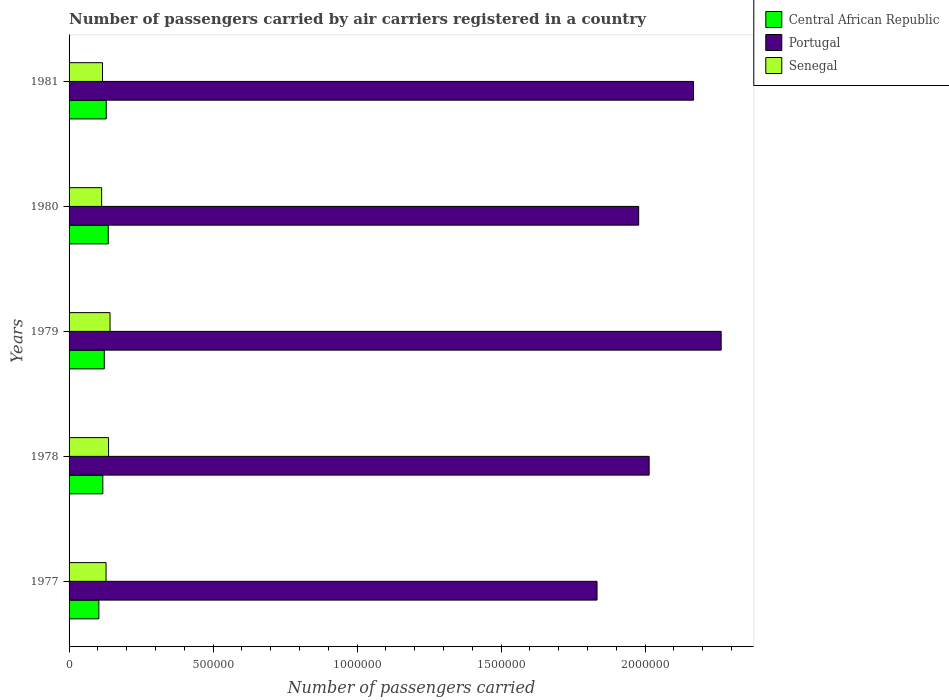What is the label of the 4th group of bars from the top?
Your response must be concise. 1978. What is the number of passengers carried by air carriers in Central African Republic in 1981?
Keep it short and to the point. 1.29e+05. Across all years, what is the maximum number of passengers carried by air carriers in Senegal?
Make the answer very short. 1.42e+05. Across all years, what is the minimum number of passengers carried by air carriers in Portugal?
Offer a very short reply. 1.83e+06. What is the total number of passengers carried by air carriers in Senegal in the graph?
Ensure brevity in your answer.  6.37e+05. What is the difference between the number of passengers carried by air carriers in Senegal in 1977 and that in 1978?
Provide a short and direct response. -8800. What is the difference between the number of passengers carried by air carriers in Portugal in 1981 and the number of passengers carried by air carriers in Central African Republic in 1979?
Provide a short and direct response. 2.05e+06. What is the average number of passengers carried by air carriers in Portugal per year?
Offer a terse response. 2.05e+06. In the year 1977, what is the difference between the number of passengers carried by air carriers in Central African Republic and number of passengers carried by air carriers in Senegal?
Your answer should be very brief. -2.50e+04. In how many years, is the number of passengers carried by air carriers in Central African Republic greater than 1900000 ?
Provide a succinct answer. 0. What is the ratio of the number of passengers carried by air carriers in Portugal in 1977 to that in 1979?
Keep it short and to the point. 0.81. What is the difference between the highest and the second highest number of passengers carried by air carriers in Portugal?
Offer a terse response. 9.60e+04. What is the difference between the highest and the lowest number of passengers carried by air carriers in Central African Republic?
Provide a succinct answer. 3.27e+04. In how many years, is the number of passengers carried by air carriers in Portugal greater than the average number of passengers carried by air carriers in Portugal taken over all years?
Offer a terse response. 2. What does the 1st bar from the top in 1980 represents?
Give a very brief answer. Senegal. How many bars are there?
Make the answer very short. 15. Does the graph contain any zero values?
Make the answer very short. No. Where does the legend appear in the graph?
Offer a terse response. Top right. How many legend labels are there?
Your answer should be very brief. 3. What is the title of the graph?
Your answer should be compact. Number of passengers carried by air carriers registered in a country. What is the label or title of the X-axis?
Offer a very short reply. Number of passengers carried. What is the label or title of the Y-axis?
Your response must be concise. Years. What is the Number of passengers carried in Central African Republic in 1977?
Make the answer very short. 1.03e+05. What is the Number of passengers carried of Portugal in 1977?
Offer a terse response. 1.83e+06. What is the Number of passengers carried of Senegal in 1977?
Your answer should be compact. 1.28e+05. What is the Number of passengers carried in Central African Republic in 1978?
Your response must be concise. 1.17e+05. What is the Number of passengers carried of Portugal in 1978?
Your answer should be compact. 2.01e+06. What is the Number of passengers carried in Senegal in 1978?
Your answer should be very brief. 1.37e+05. What is the Number of passengers carried of Central African Republic in 1979?
Give a very brief answer. 1.22e+05. What is the Number of passengers carried of Portugal in 1979?
Offer a very short reply. 2.26e+06. What is the Number of passengers carried in Senegal in 1979?
Give a very brief answer. 1.42e+05. What is the Number of passengers carried of Central African Republic in 1980?
Give a very brief answer. 1.36e+05. What is the Number of passengers carried in Portugal in 1980?
Make the answer very short. 1.98e+06. What is the Number of passengers carried of Senegal in 1980?
Your answer should be very brief. 1.13e+05. What is the Number of passengers carried in Central African Republic in 1981?
Provide a succinct answer. 1.29e+05. What is the Number of passengers carried of Portugal in 1981?
Make the answer very short. 2.17e+06. What is the Number of passengers carried in Senegal in 1981?
Ensure brevity in your answer.  1.16e+05. Across all years, what is the maximum Number of passengers carried of Central African Republic?
Offer a very short reply. 1.36e+05. Across all years, what is the maximum Number of passengers carried of Portugal?
Give a very brief answer. 2.26e+06. Across all years, what is the maximum Number of passengers carried in Senegal?
Your response must be concise. 1.42e+05. Across all years, what is the minimum Number of passengers carried in Central African Republic?
Provide a short and direct response. 1.03e+05. Across all years, what is the minimum Number of passengers carried in Portugal?
Offer a very short reply. 1.83e+06. Across all years, what is the minimum Number of passengers carried in Senegal?
Your response must be concise. 1.13e+05. What is the total Number of passengers carried in Central African Republic in the graph?
Your response must be concise. 6.08e+05. What is the total Number of passengers carried in Portugal in the graph?
Give a very brief answer. 1.03e+07. What is the total Number of passengers carried of Senegal in the graph?
Offer a terse response. 6.37e+05. What is the difference between the Number of passengers carried of Central African Republic in 1977 and that in 1978?
Your response must be concise. -1.38e+04. What is the difference between the Number of passengers carried in Portugal in 1977 and that in 1978?
Offer a very short reply. -1.81e+05. What is the difference between the Number of passengers carried of Senegal in 1977 and that in 1978?
Your answer should be very brief. -8800. What is the difference between the Number of passengers carried in Central African Republic in 1977 and that in 1979?
Offer a terse response. -1.89e+04. What is the difference between the Number of passengers carried in Portugal in 1977 and that in 1979?
Ensure brevity in your answer.  -4.31e+05. What is the difference between the Number of passengers carried in Senegal in 1977 and that in 1979?
Offer a very short reply. -1.39e+04. What is the difference between the Number of passengers carried of Central African Republic in 1977 and that in 1980?
Make the answer very short. -3.27e+04. What is the difference between the Number of passengers carried in Portugal in 1977 and that in 1980?
Keep it short and to the point. -1.45e+05. What is the difference between the Number of passengers carried in Senegal in 1977 and that in 1980?
Keep it short and to the point. 1.53e+04. What is the difference between the Number of passengers carried in Central African Republic in 1977 and that in 1981?
Your response must be concise. -2.57e+04. What is the difference between the Number of passengers carried of Portugal in 1977 and that in 1981?
Your response must be concise. -3.35e+05. What is the difference between the Number of passengers carried of Senegal in 1977 and that in 1981?
Ensure brevity in your answer.  1.23e+04. What is the difference between the Number of passengers carried in Central African Republic in 1978 and that in 1979?
Your answer should be compact. -5100. What is the difference between the Number of passengers carried in Portugal in 1978 and that in 1979?
Give a very brief answer. -2.50e+05. What is the difference between the Number of passengers carried in Senegal in 1978 and that in 1979?
Your answer should be very brief. -5100. What is the difference between the Number of passengers carried of Central African Republic in 1978 and that in 1980?
Give a very brief answer. -1.89e+04. What is the difference between the Number of passengers carried in Portugal in 1978 and that in 1980?
Offer a very short reply. 3.63e+04. What is the difference between the Number of passengers carried in Senegal in 1978 and that in 1980?
Your answer should be very brief. 2.41e+04. What is the difference between the Number of passengers carried in Central African Republic in 1978 and that in 1981?
Give a very brief answer. -1.19e+04. What is the difference between the Number of passengers carried of Portugal in 1978 and that in 1981?
Your answer should be compact. -1.54e+05. What is the difference between the Number of passengers carried in Senegal in 1978 and that in 1981?
Your answer should be compact. 2.11e+04. What is the difference between the Number of passengers carried of Central African Republic in 1979 and that in 1980?
Provide a succinct answer. -1.38e+04. What is the difference between the Number of passengers carried in Portugal in 1979 and that in 1980?
Your response must be concise. 2.86e+05. What is the difference between the Number of passengers carried of Senegal in 1979 and that in 1980?
Offer a very short reply. 2.92e+04. What is the difference between the Number of passengers carried of Central African Republic in 1979 and that in 1981?
Offer a very short reply. -6800. What is the difference between the Number of passengers carried in Portugal in 1979 and that in 1981?
Provide a short and direct response. 9.60e+04. What is the difference between the Number of passengers carried of Senegal in 1979 and that in 1981?
Ensure brevity in your answer.  2.62e+04. What is the difference between the Number of passengers carried in Central African Republic in 1980 and that in 1981?
Keep it short and to the point. 7000. What is the difference between the Number of passengers carried of Portugal in 1980 and that in 1981?
Offer a very short reply. -1.90e+05. What is the difference between the Number of passengers carried of Senegal in 1980 and that in 1981?
Ensure brevity in your answer.  -3000. What is the difference between the Number of passengers carried in Central African Republic in 1977 and the Number of passengers carried in Portugal in 1978?
Your response must be concise. -1.91e+06. What is the difference between the Number of passengers carried of Central African Republic in 1977 and the Number of passengers carried of Senegal in 1978?
Provide a short and direct response. -3.38e+04. What is the difference between the Number of passengers carried in Portugal in 1977 and the Number of passengers carried in Senegal in 1978?
Your answer should be very brief. 1.70e+06. What is the difference between the Number of passengers carried in Central African Republic in 1977 and the Number of passengers carried in Portugal in 1979?
Keep it short and to the point. -2.16e+06. What is the difference between the Number of passengers carried of Central African Republic in 1977 and the Number of passengers carried of Senegal in 1979?
Provide a short and direct response. -3.89e+04. What is the difference between the Number of passengers carried of Portugal in 1977 and the Number of passengers carried of Senegal in 1979?
Keep it short and to the point. 1.69e+06. What is the difference between the Number of passengers carried of Central African Republic in 1977 and the Number of passengers carried of Portugal in 1980?
Provide a short and direct response. -1.87e+06. What is the difference between the Number of passengers carried in Central African Republic in 1977 and the Number of passengers carried in Senegal in 1980?
Make the answer very short. -9700. What is the difference between the Number of passengers carried in Portugal in 1977 and the Number of passengers carried in Senegal in 1980?
Your response must be concise. 1.72e+06. What is the difference between the Number of passengers carried of Central African Republic in 1977 and the Number of passengers carried of Portugal in 1981?
Your answer should be compact. -2.07e+06. What is the difference between the Number of passengers carried in Central African Republic in 1977 and the Number of passengers carried in Senegal in 1981?
Make the answer very short. -1.27e+04. What is the difference between the Number of passengers carried of Portugal in 1977 and the Number of passengers carried of Senegal in 1981?
Keep it short and to the point. 1.72e+06. What is the difference between the Number of passengers carried of Central African Republic in 1978 and the Number of passengers carried of Portugal in 1979?
Ensure brevity in your answer.  -2.15e+06. What is the difference between the Number of passengers carried of Central African Republic in 1978 and the Number of passengers carried of Senegal in 1979?
Offer a terse response. -2.51e+04. What is the difference between the Number of passengers carried of Portugal in 1978 and the Number of passengers carried of Senegal in 1979?
Give a very brief answer. 1.87e+06. What is the difference between the Number of passengers carried in Central African Republic in 1978 and the Number of passengers carried in Portugal in 1980?
Ensure brevity in your answer.  -1.86e+06. What is the difference between the Number of passengers carried in Central African Republic in 1978 and the Number of passengers carried in Senegal in 1980?
Your answer should be compact. 4100. What is the difference between the Number of passengers carried in Portugal in 1978 and the Number of passengers carried in Senegal in 1980?
Offer a very short reply. 1.90e+06. What is the difference between the Number of passengers carried in Central African Republic in 1978 and the Number of passengers carried in Portugal in 1981?
Ensure brevity in your answer.  -2.05e+06. What is the difference between the Number of passengers carried in Central African Republic in 1978 and the Number of passengers carried in Senegal in 1981?
Offer a very short reply. 1100. What is the difference between the Number of passengers carried of Portugal in 1978 and the Number of passengers carried of Senegal in 1981?
Provide a succinct answer. 1.90e+06. What is the difference between the Number of passengers carried in Central African Republic in 1979 and the Number of passengers carried in Portugal in 1980?
Your answer should be very brief. -1.86e+06. What is the difference between the Number of passengers carried in Central African Republic in 1979 and the Number of passengers carried in Senegal in 1980?
Provide a succinct answer. 9200. What is the difference between the Number of passengers carried of Portugal in 1979 and the Number of passengers carried of Senegal in 1980?
Ensure brevity in your answer.  2.15e+06. What is the difference between the Number of passengers carried in Central African Republic in 1979 and the Number of passengers carried in Portugal in 1981?
Make the answer very short. -2.05e+06. What is the difference between the Number of passengers carried in Central African Republic in 1979 and the Number of passengers carried in Senegal in 1981?
Keep it short and to the point. 6200. What is the difference between the Number of passengers carried of Portugal in 1979 and the Number of passengers carried of Senegal in 1981?
Provide a short and direct response. 2.15e+06. What is the difference between the Number of passengers carried of Central African Republic in 1980 and the Number of passengers carried of Portugal in 1981?
Your response must be concise. -2.03e+06. What is the difference between the Number of passengers carried in Portugal in 1980 and the Number of passengers carried in Senegal in 1981?
Your answer should be compact. 1.86e+06. What is the average Number of passengers carried in Central African Republic per year?
Your answer should be compact. 1.22e+05. What is the average Number of passengers carried of Portugal per year?
Your response must be concise. 2.05e+06. What is the average Number of passengers carried of Senegal per year?
Give a very brief answer. 1.27e+05. In the year 1977, what is the difference between the Number of passengers carried of Central African Republic and Number of passengers carried of Portugal?
Your answer should be compact. -1.73e+06. In the year 1977, what is the difference between the Number of passengers carried in Central African Republic and Number of passengers carried in Senegal?
Keep it short and to the point. -2.50e+04. In the year 1977, what is the difference between the Number of passengers carried of Portugal and Number of passengers carried of Senegal?
Keep it short and to the point. 1.70e+06. In the year 1978, what is the difference between the Number of passengers carried of Central African Republic and Number of passengers carried of Portugal?
Keep it short and to the point. -1.90e+06. In the year 1978, what is the difference between the Number of passengers carried of Central African Republic and Number of passengers carried of Senegal?
Make the answer very short. -2.00e+04. In the year 1978, what is the difference between the Number of passengers carried in Portugal and Number of passengers carried in Senegal?
Provide a succinct answer. 1.88e+06. In the year 1979, what is the difference between the Number of passengers carried of Central African Republic and Number of passengers carried of Portugal?
Give a very brief answer. -2.14e+06. In the year 1979, what is the difference between the Number of passengers carried of Portugal and Number of passengers carried of Senegal?
Provide a succinct answer. 2.12e+06. In the year 1980, what is the difference between the Number of passengers carried of Central African Republic and Number of passengers carried of Portugal?
Give a very brief answer. -1.84e+06. In the year 1980, what is the difference between the Number of passengers carried in Central African Republic and Number of passengers carried in Senegal?
Make the answer very short. 2.30e+04. In the year 1980, what is the difference between the Number of passengers carried of Portugal and Number of passengers carried of Senegal?
Provide a succinct answer. 1.86e+06. In the year 1981, what is the difference between the Number of passengers carried of Central African Republic and Number of passengers carried of Portugal?
Give a very brief answer. -2.04e+06. In the year 1981, what is the difference between the Number of passengers carried of Central African Republic and Number of passengers carried of Senegal?
Offer a very short reply. 1.30e+04. In the year 1981, what is the difference between the Number of passengers carried in Portugal and Number of passengers carried in Senegal?
Ensure brevity in your answer.  2.05e+06. What is the ratio of the Number of passengers carried of Central African Republic in 1977 to that in 1978?
Your answer should be compact. 0.88. What is the ratio of the Number of passengers carried in Portugal in 1977 to that in 1978?
Give a very brief answer. 0.91. What is the ratio of the Number of passengers carried in Senegal in 1977 to that in 1978?
Your answer should be compact. 0.94. What is the ratio of the Number of passengers carried of Central African Republic in 1977 to that in 1979?
Your response must be concise. 0.85. What is the ratio of the Number of passengers carried of Portugal in 1977 to that in 1979?
Ensure brevity in your answer.  0.81. What is the ratio of the Number of passengers carried of Senegal in 1977 to that in 1979?
Keep it short and to the point. 0.9. What is the ratio of the Number of passengers carried of Central African Republic in 1977 to that in 1980?
Your response must be concise. 0.76. What is the ratio of the Number of passengers carried of Portugal in 1977 to that in 1980?
Make the answer very short. 0.93. What is the ratio of the Number of passengers carried of Senegal in 1977 to that in 1980?
Ensure brevity in your answer.  1.14. What is the ratio of the Number of passengers carried in Central African Republic in 1977 to that in 1981?
Ensure brevity in your answer.  0.8. What is the ratio of the Number of passengers carried of Portugal in 1977 to that in 1981?
Offer a terse response. 0.85. What is the ratio of the Number of passengers carried of Senegal in 1977 to that in 1981?
Offer a terse response. 1.11. What is the ratio of the Number of passengers carried of Portugal in 1978 to that in 1979?
Your answer should be compact. 0.89. What is the ratio of the Number of passengers carried of Senegal in 1978 to that in 1979?
Keep it short and to the point. 0.96. What is the ratio of the Number of passengers carried in Central African Republic in 1978 to that in 1980?
Keep it short and to the point. 0.86. What is the ratio of the Number of passengers carried in Portugal in 1978 to that in 1980?
Ensure brevity in your answer.  1.02. What is the ratio of the Number of passengers carried of Senegal in 1978 to that in 1980?
Make the answer very short. 1.21. What is the ratio of the Number of passengers carried in Central African Republic in 1978 to that in 1981?
Your answer should be very brief. 0.91. What is the ratio of the Number of passengers carried of Portugal in 1978 to that in 1981?
Provide a short and direct response. 0.93. What is the ratio of the Number of passengers carried in Senegal in 1978 to that in 1981?
Your response must be concise. 1.18. What is the ratio of the Number of passengers carried in Central African Republic in 1979 to that in 1980?
Keep it short and to the point. 0.9. What is the ratio of the Number of passengers carried of Portugal in 1979 to that in 1980?
Provide a succinct answer. 1.14. What is the ratio of the Number of passengers carried in Senegal in 1979 to that in 1980?
Ensure brevity in your answer.  1.26. What is the ratio of the Number of passengers carried of Central African Republic in 1979 to that in 1981?
Ensure brevity in your answer.  0.95. What is the ratio of the Number of passengers carried of Portugal in 1979 to that in 1981?
Provide a short and direct response. 1.04. What is the ratio of the Number of passengers carried of Senegal in 1979 to that in 1981?
Make the answer very short. 1.23. What is the ratio of the Number of passengers carried in Central African Republic in 1980 to that in 1981?
Keep it short and to the point. 1.05. What is the ratio of the Number of passengers carried in Portugal in 1980 to that in 1981?
Offer a terse response. 0.91. What is the ratio of the Number of passengers carried of Senegal in 1980 to that in 1981?
Give a very brief answer. 0.97. What is the difference between the highest and the second highest Number of passengers carried in Central African Republic?
Provide a short and direct response. 7000. What is the difference between the highest and the second highest Number of passengers carried of Portugal?
Keep it short and to the point. 9.60e+04. What is the difference between the highest and the second highest Number of passengers carried in Senegal?
Keep it short and to the point. 5100. What is the difference between the highest and the lowest Number of passengers carried in Central African Republic?
Give a very brief answer. 3.27e+04. What is the difference between the highest and the lowest Number of passengers carried in Portugal?
Offer a terse response. 4.31e+05. What is the difference between the highest and the lowest Number of passengers carried of Senegal?
Your response must be concise. 2.92e+04. 